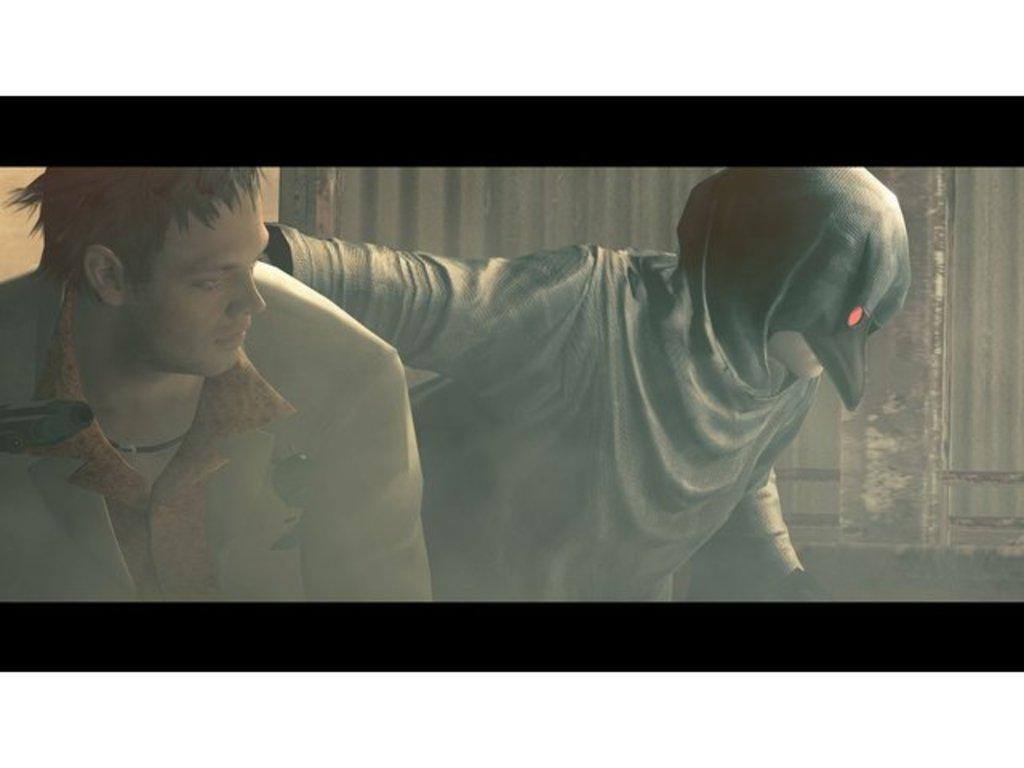What type of image is being described? The image is an animation. How many people are present in the image? There are two persons in the image. What can be seen in the background of the image? There appears to be a building in the background of the image. What type of spot is visible on the building in the image? There is no spot visible on the building in the image, as the provided facts do not mention any spots or specific details about the building. 